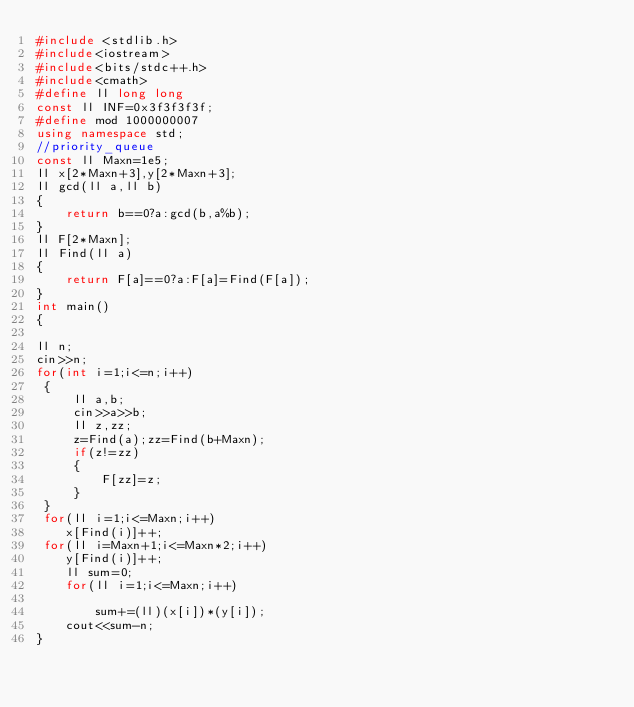<code> <loc_0><loc_0><loc_500><loc_500><_C++_>#include <stdlib.h>
#include<iostream>
#include<bits/stdc++.h>
#include<cmath>
#define ll long long
const ll INF=0x3f3f3f3f;
#define mod 1000000007
using namespace std;
//priority_queue
const ll Maxn=1e5;
ll x[2*Maxn+3],y[2*Maxn+3];
ll gcd(ll a,ll b)
{
    return b==0?a:gcd(b,a%b);
}
ll F[2*Maxn];
ll Find(ll a)
{
    return F[a]==0?a:F[a]=Find(F[a]);
}
int main()
{

ll n;
cin>>n;
for(int i=1;i<=n;i++)
 {
     ll a,b;
     cin>>a>>b;
     ll z,zz;
     z=Find(a);zz=Find(b+Maxn);
     if(z!=zz)
     {
         F[zz]=z;
     }
 }
 for(ll i=1;i<=Maxn;i++)
    x[Find(i)]++;
 for(ll i=Maxn+1;i<=Maxn*2;i++)
    y[Find(i)]++;
    ll sum=0;
    for(ll i=1;i<=Maxn;i++)
      
        sum+=(ll)(x[i])*(y[i]);
    cout<<sum-n;
}

</code> 